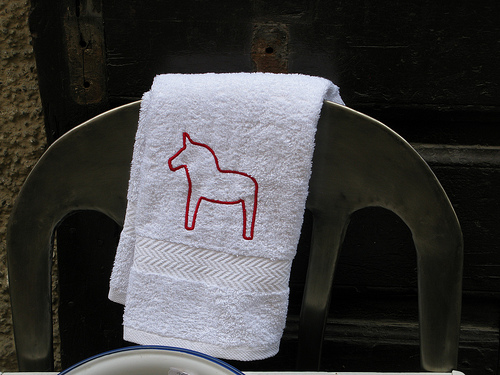<image>
Is there a unicorn above the chair? No. The unicorn is not positioned above the chair. The vertical arrangement shows a different relationship. Is the cloth on the chair? Yes. Looking at the image, I can see the cloth is positioned on top of the chair, with the chair providing support. 